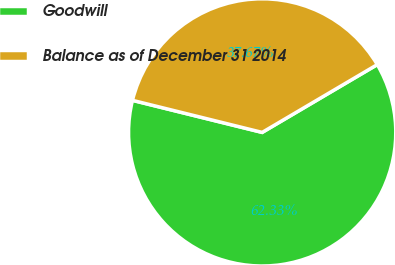Convert chart. <chart><loc_0><loc_0><loc_500><loc_500><pie_chart><fcel>Goodwill<fcel>Balance as of December 31 2014<nl><fcel>62.33%<fcel>37.67%<nl></chart> 